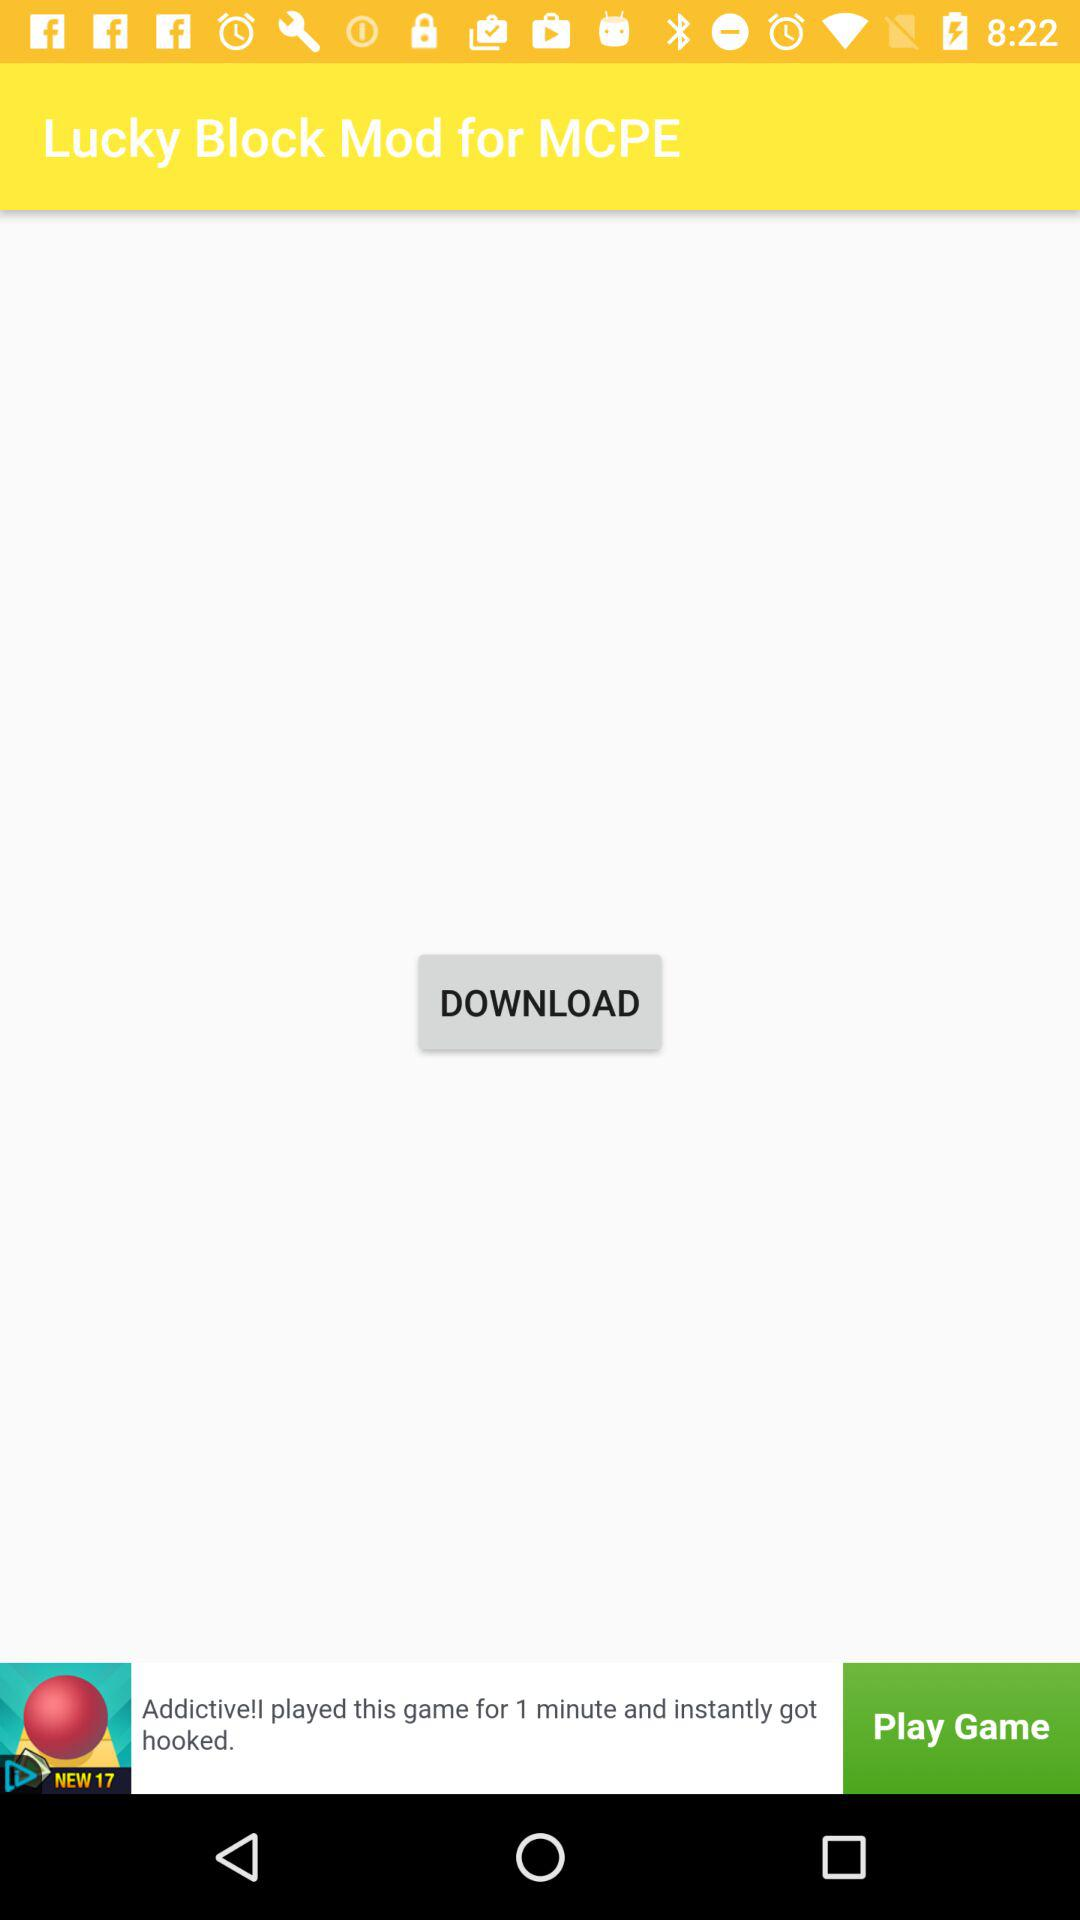What is the application name? The application name is "Lucky Block Mod for MCPE". 